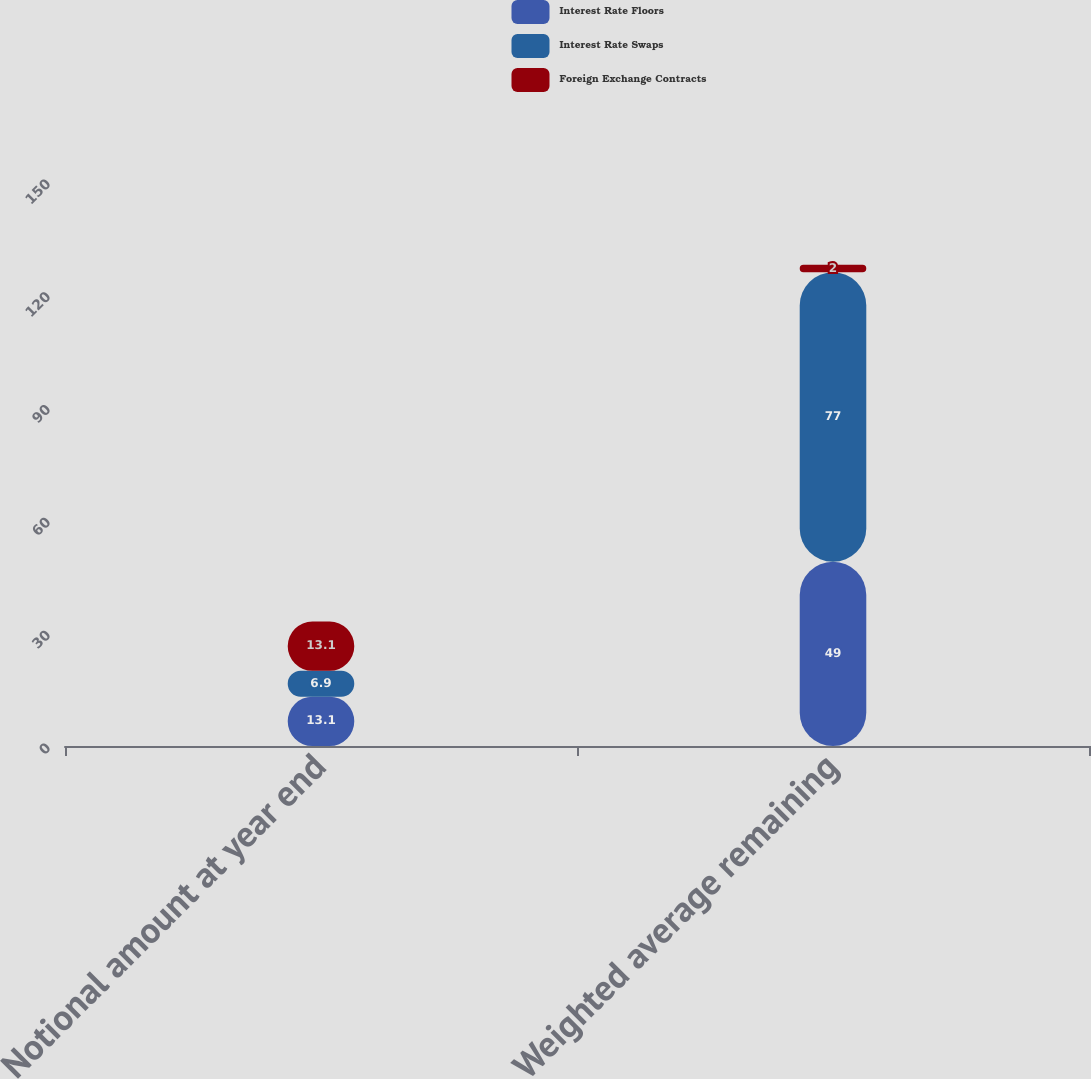<chart> <loc_0><loc_0><loc_500><loc_500><stacked_bar_chart><ecel><fcel>Notional amount at year end<fcel>Weighted average remaining<nl><fcel>Interest Rate Floors<fcel>13.1<fcel>49<nl><fcel>Interest Rate Swaps<fcel>6.9<fcel>77<nl><fcel>Foreign Exchange Contracts<fcel>13.1<fcel>2<nl></chart> 